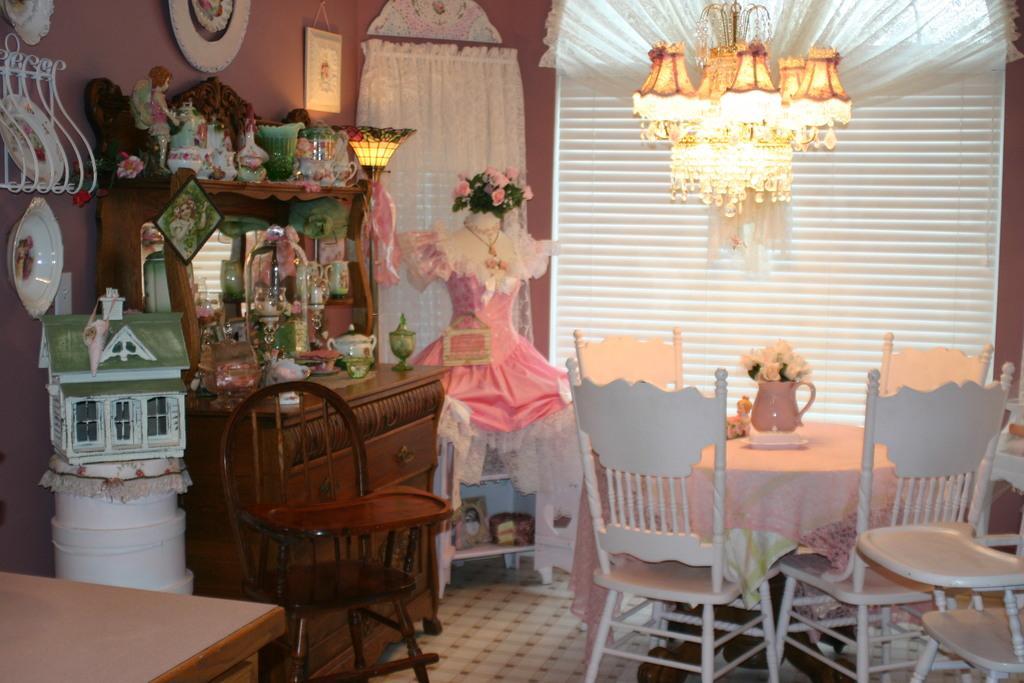How would you summarize this image in a sentence or two? In this image I can see few tables and few chairs, lights, wall and the curtain. 